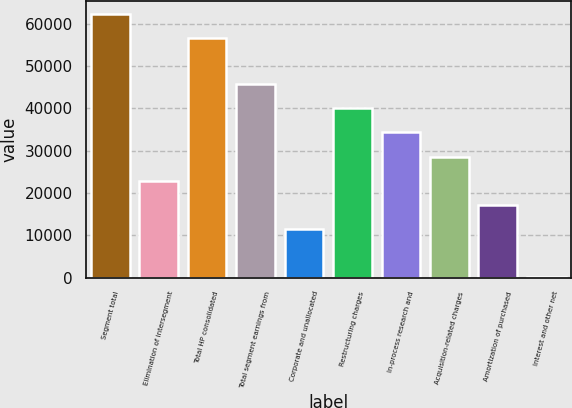<chart> <loc_0><loc_0><loc_500><loc_500><bar_chart><fcel>Segment total<fcel>Elimination of intersegment<fcel>Total HP consolidated<fcel>Total segment earnings from<fcel>Corporate and unallocated<fcel>Restructuring charges<fcel>In-process research and<fcel>Acquisition-related charges<fcel>Amortization of purchased<fcel>Interest and other net<nl><fcel>62301.8<fcel>22907.2<fcel>56588<fcel>45762.4<fcel>11479.6<fcel>40048.6<fcel>34334.8<fcel>28621<fcel>17193.4<fcel>52<nl></chart> 